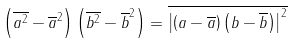<formula> <loc_0><loc_0><loc_500><loc_500>\left ( \overline { { { a } ^ { 2 } } } - { { \overline { a } } ^ { 2 } } \right ) \left ( \overline { { { b } ^ { 2 } } } - { { \overline { b } } ^ { 2 } } \right ) = \overline { { { \left | \left ( a - \overline { a } \right ) \left ( b - \overline { b } \right ) \right | } ^ { 2 } } }</formula> 